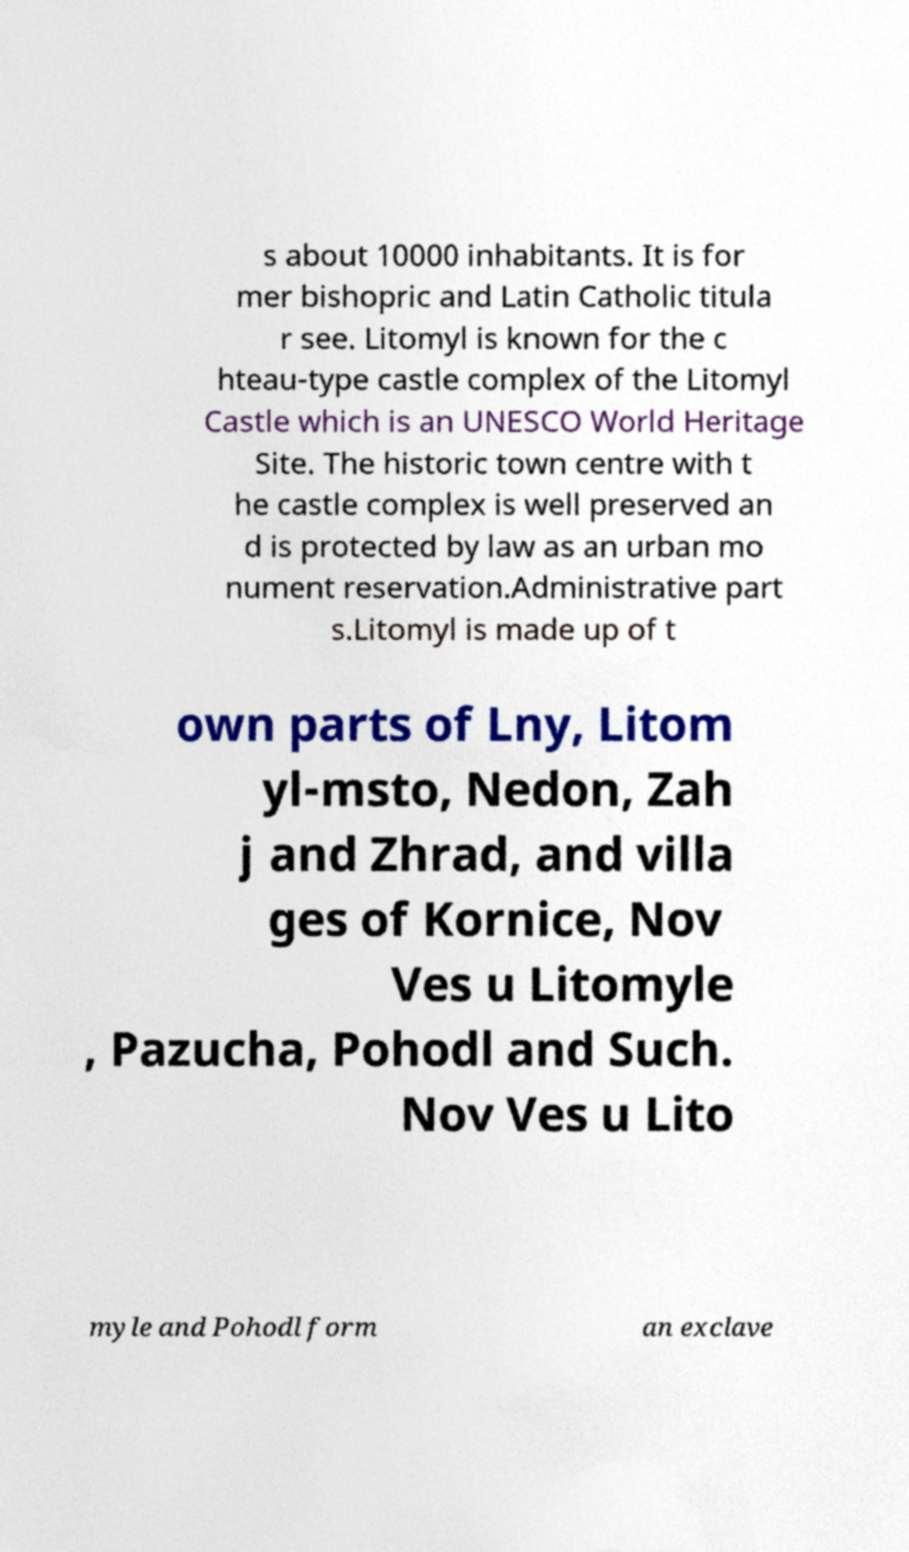Can you accurately transcribe the text from the provided image for me? s about 10000 inhabitants. It is for mer bishopric and Latin Catholic titula r see. Litomyl is known for the c hteau-type castle complex of the Litomyl Castle which is an UNESCO World Heritage Site. The historic town centre with t he castle complex is well preserved an d is protected by law as an urban mo nument reservation.Administrative part s.Litomyl is made up of t own parts of Lny, Litom yl-msto, Nedon, Zah j and Zhrad, and villa ges of Kornice, Nov Ves u Litomyle , Pazucha, Pohodl and Such. Nov Ves u Lito myle and Pohodl form an exclave 